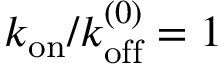Convert formula to latex. <formula><loc_0><loc_0><loc_500><loc_500>k _ { o n } / k _ { o f f } ^ { ( 0 ) } = 1</formula> 